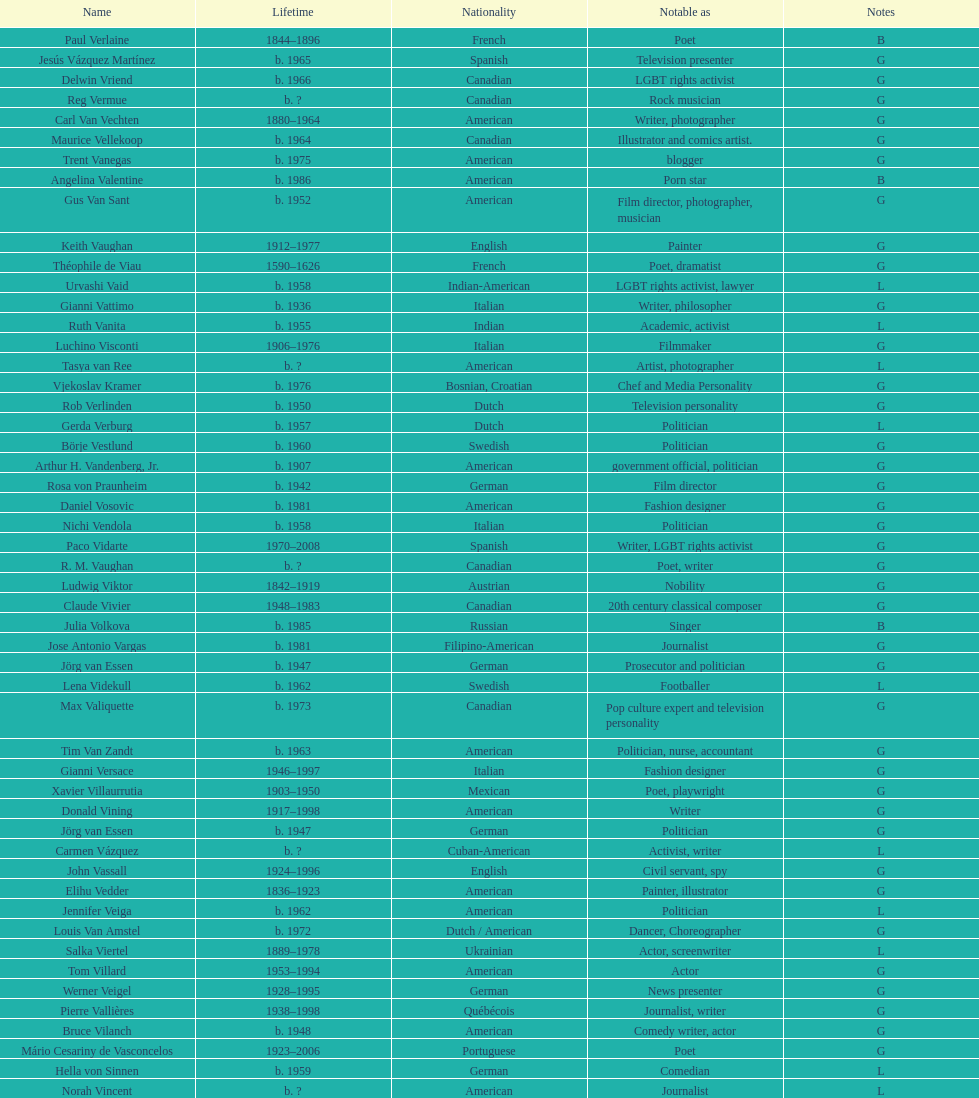Who was canadian, van amstel or valiquette? Valiquette. 